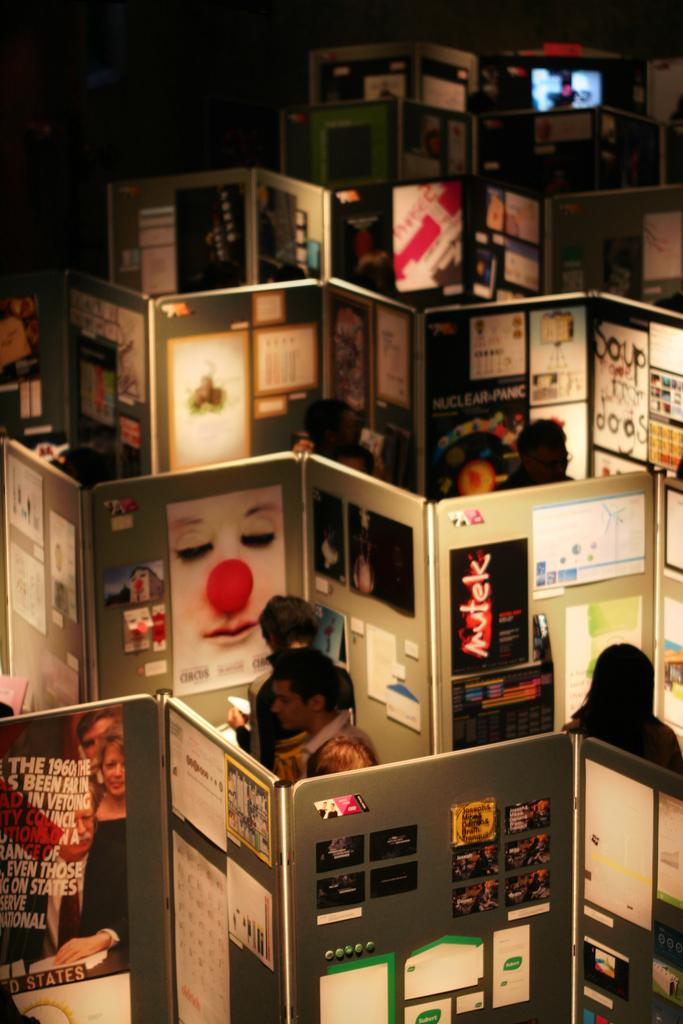Who or what is present in the image? There are people in the image. What can be seen on the walls in the image? There are walls with posters in the image. What is located in the background of the image? There is a screen in the background of the image. What grade of ants can be seen crawling on the people in the image? There are no ants present in the image, so it is not possible to determine the grade of ants. 